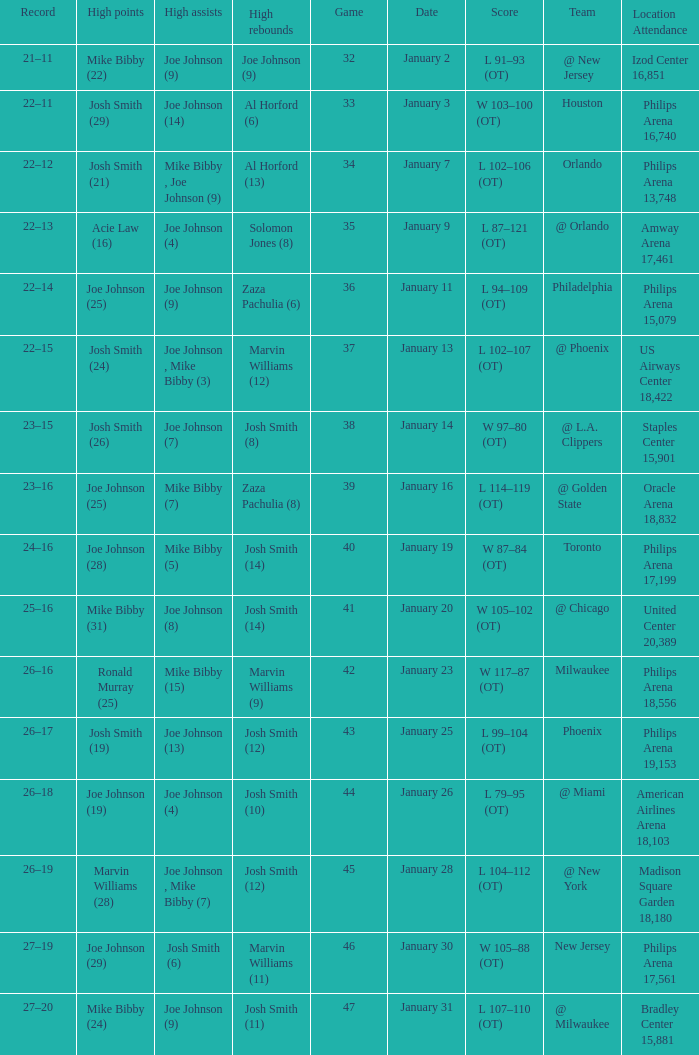Which date was game 35 on? January 9. Can you parse all the data within this table? {'header': ['Record', 'High points', 'High assists', 'High rebounds', 'Game', 'Date', 'Score', 'Team', 'Location Attendance'], 'rows': [['21–11', 'Mike Bibby (22)', 'Joe Johnson (9)', 'Joe Johnson (9)', '32', 'January 2', 'L 91–93 (OT)', '@ New Jersey', 'Izod Center 16,851'], ['22–11', 'Josh Smith (29)', 'Joe Johnson (14)', 'Al Horford (6)', '33', 'January 3', 'W 103–100 (OT)', 'Houston', 'Philips Arena 16,740'], ['22–12', 'Josh Smith (21)', 'Mike Bibby , Joe Johnson (9)', 'Al Horford (13)', '34', 'January 7', 'L 102–106 (OT)', 'Orlando', 'Philips Arena 13,748'], ['22–13', 'Acie Law (16)', 'Joe Johnson (4)', 'Solomon Jones (8)', '35', 'January 9', 'L 87–121 (OT)', '@ Orlando', 'Amway Arena 17,461'], ['22–14', 'Joe Johnson (25)', 'Joe Johnson (9)', 'Zaza Pachulia (6)', '36', 'January 11', 'L 94–109 (OT)', 'Philadelphia', 'Philips Arena 15,079'], ['22–15', 'Josh Smith (24)', 'Joe Johnson , Mike Bibby (3)', 'Marvin Williams (12)', '37', 'January 13', 'L 102–107 (OT)', '@ Phoenix', 'US Airways Center 18,422'], ['23–15', 'Josh Smith (26)', 'Joe Johnson (7)', 'Josh Smith (8)', '38', 'January 14', 'W 97–80 (OT)', '@ L.A. Clippers', 'Staples Center 15,901'], ['23–16', 'Joe Johnson (25)', 'Mike Bibby (7)', 'Zaza Pachulia (8)', '39', 'January 16', 'L 114–119 (OT)', '@ Golden State', 'Oracle Arena 18,832'], ['24–16', 'Joe Johnson (28)', 'Mike Bibby (5)', 'Josh Smith (14)', '40', 'January 19', 'W 87–84 (OT)', 'Toronto', 'Philips Arena 17,199'], ['25–16', 'Mike Bibby (31)', 'Joe Johnson (8)', 'Josh Smith (14)', '41', 'January 20', 'W 105–102 (OT)', '@ Chicago', 'United Center 20,389'], ['26–16', 'Ronald Murray (25)', 'Mike Bibby (15)', 'Marvin Williams (9)', '42', 'January 23', 'W 117–87 (OT)', 'Milwaukee', 'Philips Arena 18,556'], ['26–17', 'Josh Smith (19)', 'Joe Johnson (13)', 'Josh Smith (12)', '43', 'January 25', 'L 99–104 (OT)', 'Phoenix', 'Philips Arena 19,153'], ['26–18', 'Joe Johnson (19)', 'Joe Johnson (4)', 'Josh Smith (10)', '44', 'January 26', 'L 79–95 (OT)', '@ Miami', 'American Airlines Arena 18,103'], ['26–19', 'Marvin Williams (28)', 'Joe Johnson , Mike Bibby (7)', 'Josh Smith (12)', '45', 'January 28', 'L 104–112 (OT)', '@ New York', 'Madison Square Garden 18,180'], ['27–19', 'Joe Johnson (29)', 'Josh Smith (6)', 'Marvin Williams (11)', '46', 'January 30', 'W 105–88 (OT)', 'New Jersey', 'Philips Arena 17,561'], ['27–20', 'Mike Bibby (24)', 'Joe Johnson (9)', 'Josh Smith (11)', '47', 'January 31', 'L 107–110 (OT)', '@ Milwaukee', 'Bradley Center 15,881']]} 